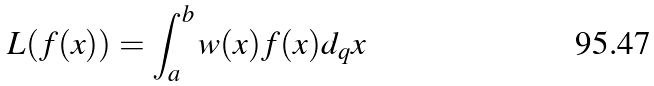Convert formula to latex. <formula><loc_0><loc_0><loc_500><loc_500>L ( f ( x ) ) = \int _ { a } ^ { b } w ( x ) f ( x ) d _ { q } x</formula> 